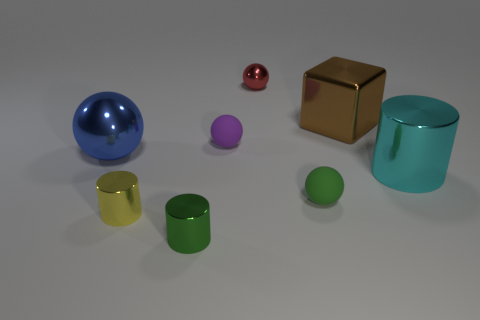Are there any other things that are made of the same material as the red sphere?
Make the answer very short. Yes. What number of metal things are small cylinders or small spheres?
Your response must be concise. 3. How many other objects are there of the same shape as the brown object?
Your answer should be very brief. 0. Are there more large gray rubber cylinders than green spheres?
Make the answer very short. No. How big is the rubber object that is on the left side of the ball in front of the cylinder that is to the right of the small purple matte object?
Your response must be concise. Small. There is a shiny cylinder right of the brown cube; what size is it?
Give a very brief answer. Large. How many objects are either tiny metal objects or small cylinders in front of the yellow metal cylinder?
Make the answer very short. 3. How many other things are there of the same size as the purple rubber ball?
Your answer should be very brief. 4. What is the material of the tiny purple object that is the same shape as the small red thing?
Your response must be concise. Rubber. Is the number of tiny cylinders in front of the small green shiny cylinder greater than the number of red spheres?
Give a very brief answer. No. 